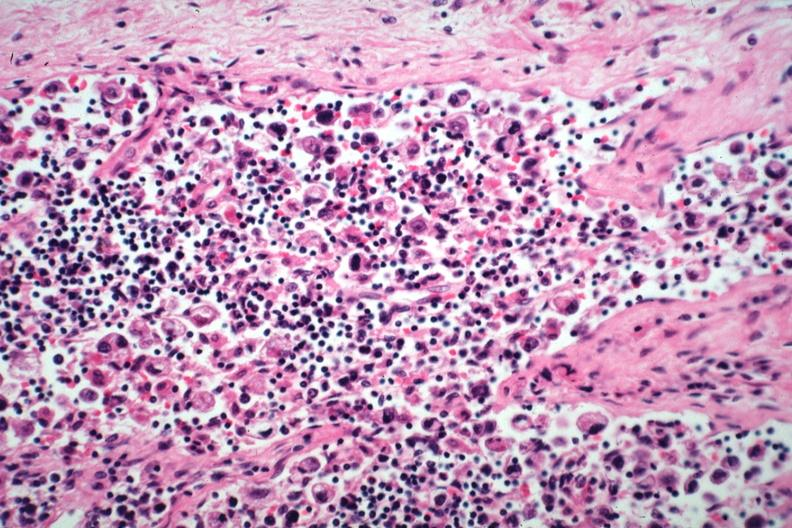what is present?
Answer the question using a single word or phrase. Metastatic carcinoma 